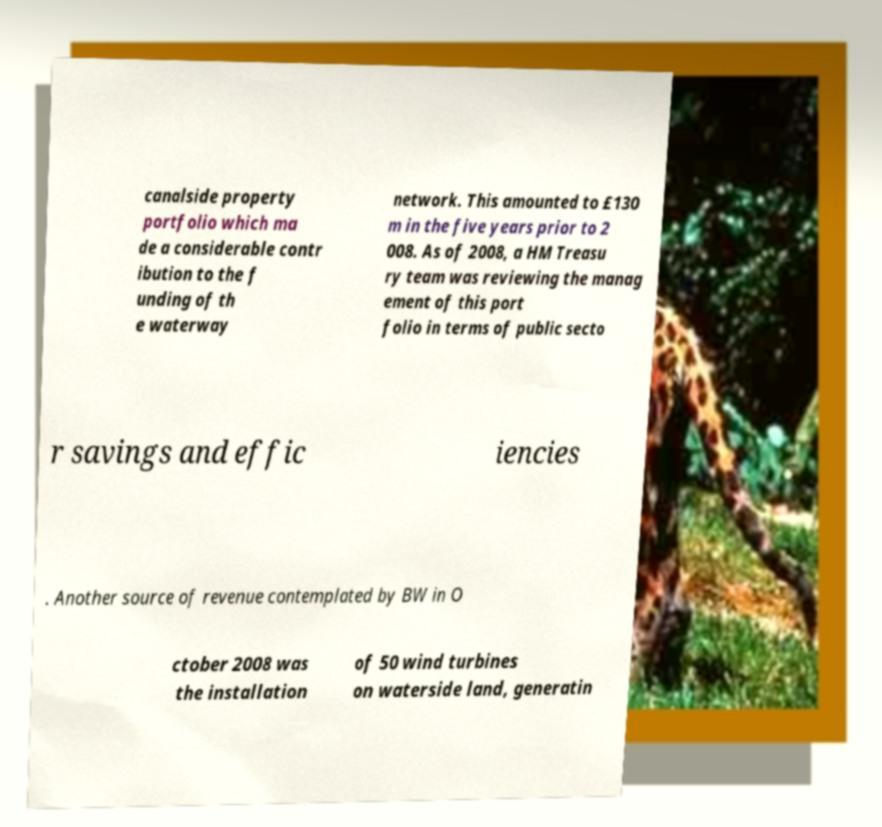What messages or text are displayed in this image? I need them in a readable, typed format. canalside property portfolio which ma de a considerable contr ibution to the f unding of th e waterway network. This amounted to £130 m in the five years prior to 2 008. As of 2008, a HM Treasu ry team was reviewing the manag ement of this port folio in terms of public secto r savings and effic iencies . Another source of revenue contemplated by BW in O ctober 2008 was the installation of 50 wind turbines on waterside land, generatin 